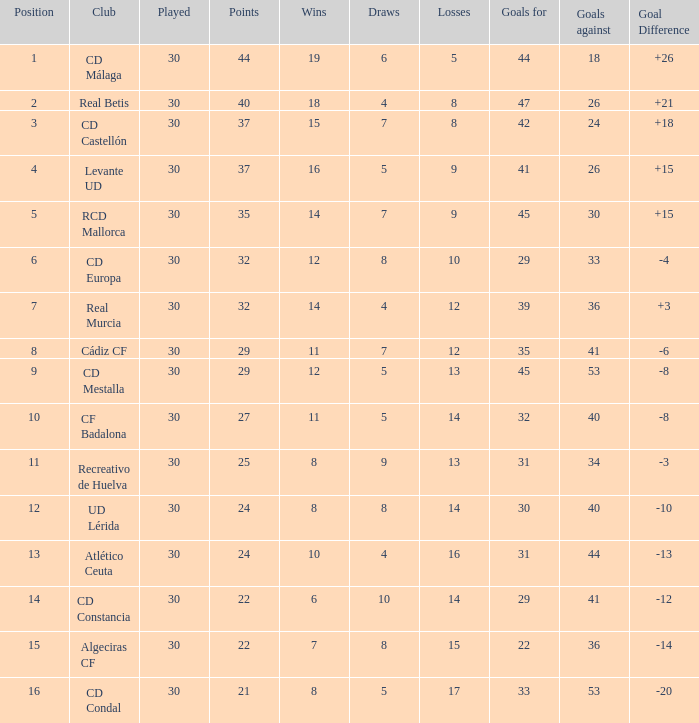What is the total of draws when played is below 30? 0.0. 